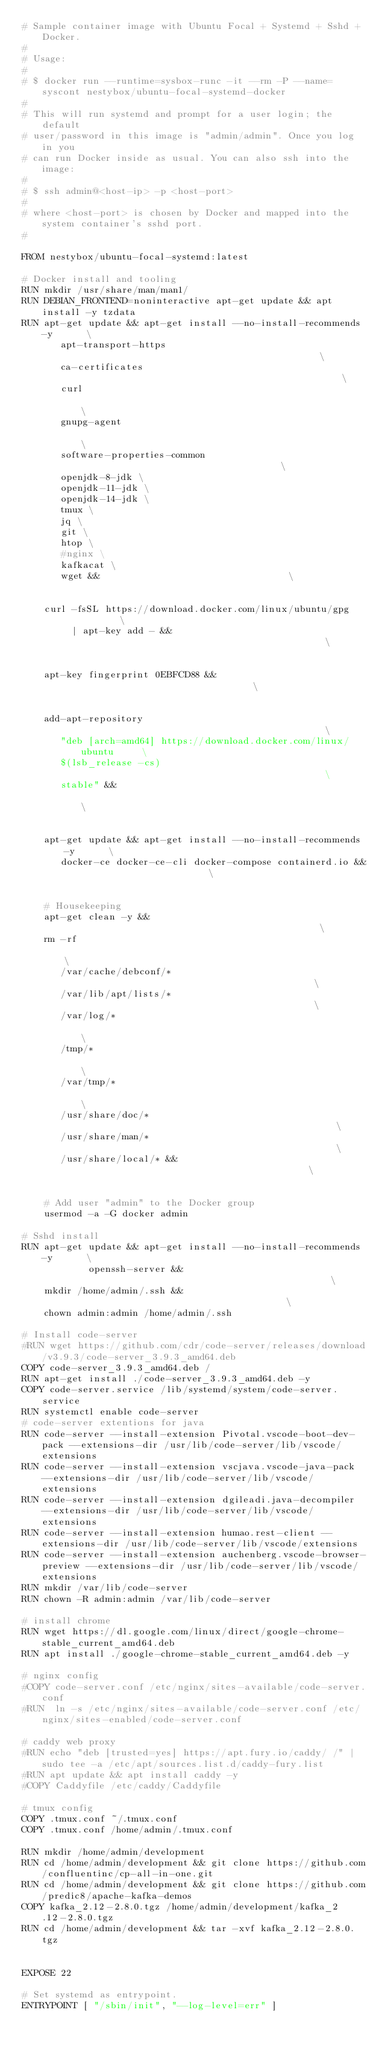Convert code to text. <code><loc_0><loc_0><loc_500><loc_500><_Dockerfile_># Sample container image with Ubuntu Focal + Systemd + Sshd + Docker.
#
# Usage:
#
# $ docker run --runtime=sysbox-runc -it --rm -P --name=syscont nestybox/ubuntu-focal-systemd-docker
#
# This will run systemd and prompt for a user login; the default
# user/password in this image is "admin/admin". Once you log in you
# can run Docker inside as usual. You can also ssh into the image:
#
# $ ssh admin@<host-ip> -p <host-port>
#
# where <host-port> is chosen by Docker and mapped into the system container's sshd port.
#

FROM nestybox/ubuntu-focal-systemd:latest

# Docker install and tooling
RUN mkdir /usr/share/man/man1/
RUN DEBIAN_FRONTEND=noninteractive apt-get update && apt install -y tzdata
RUN apt-get update && apt-get install --no-install-recommends -y      \
       apt-transport-https                                            \
       ca-certificates                                                \
       curl                                                           \
       gnupg-agent                                                    \
       software-properties-common                                     \
       openjdk-8-jdk \
       openjdk-11-jdk \
       openjdk-14-jdk \
       tmux \ 
       jq \ 
       git \
       htop \
       #nginx \
       kafkacat \
       wget &&                                  \
                                                                      \
    curl -fsSL https://download.docker.com/linux/ubuntu/gpg           \
         | apt-key add - &&                                           \
	                                                              \
    apt-key fingerprint 0EBFCD88 &&                                   \
                                                                      \
    add-apt-repository                                                \
       "deb [arch=amd64] https://download.docker.com/linux/ubuntu     \
       $(lsb_release -cs)                                             \
       stable" &&                                                     \
                                                                      \
    apt-get update && apt-get install --no-install-recommends -y      \
       docker-ce docker-ce-cli docker-compose containerd.io &&                       \
                                                                      \
    # Housekeeping
    apt-get clean -y &&                                               \
    rm -rf                                                            \
       /var/cache/debconf/*                                           \
       /var/lib/apt/lists/*                                           \
       /var/log/*                                                     \
       /tmp/*                                                         \
       /var/tmp/*                                                     \
       /usr/share/doc/*                                               \
       /usr/share/man/*                                               \
       /usr/share/local/* &&                                          \
                                                                      \
    # Add user "admin" to the Docker group
    usermod -a -G docker admin

# Sshd install
RUN apt-get update && apt-get install --no-install-recommends -y      \
            openssh-server &&                                         \
    mkdir /home/admin/.ssh &&                                         \
    chown admin:admin /home/admin/.ssh

# Install code-server
#RUN wget https://github.com/cdr/code-server/releases/download/v3.9.3/code-server_3.9.3_amd64.deb
COPY code-server_3.9.3_amd64.deb /
RUN apt-get install ./code-server_3.9.3_amd64.deb -y
COPY code-server.service /lib/systemd/system/code-server.service
RUN systemctl enable code-server
# code-server extentions for java
RUN code-server --install-extension Pivotal.vscode-boot-dev-pack --extensions-dir /usr/lib/code-server/lib/vscode/extensions
RUN code-server --install-extension vscjava.vscode-java-pack --extensions-dir /usr/lib/code-server/lib/vscode/extensions
RUN code-server --install-extension dgileadi.java-decompiler --extensions-dir /usr/lib/code-server/lib/vscode/extensions
RUN code-server --install-extension humao.rest-client --extensions-dir /usr/lib/code-server/lib/vscode/extensions
RUN code-server --install-extension auchenberg.vscode-browser-preview --extensions-dir /usr/lib/code-server/lib/vscode/extensions
RUN mkdir /var/lib/code-server
RUN chown -R admin:admin /var/lib/code-server

# install chrome
RUN wget https://dl.google.com/linux/direct/google-chrome-stable_current_amd64.deb
RUN apt install ./google-chrome-stable_current_amd64.deb -y

# nginx config
#COPY code-server.conf /etc/nginx/sites-available/code-server.conf
#RUN  ln -s /etc/nginx/sites-available/code-server.conf /etc/nginx/sites-enabled/code-server.conf

# caddy web proxy
#RUN echo "deb [trusted=yes] https://apt.fury.io/caddy/ /" | sudo tee -a /etc/apt/sources.list.d/caddy-fury.list
#RUN apt update && apt install caddy -y
#COPY Caddyfile /etc/caddy/Caddyfile

# tmux config
COPY .tmux.conf ~/.tmux.conf
COPY .tmux.conf /home/admin/.tmux.conf

RUN mkdir /home/admin/development
RUN cd /home/admin/development && git clone https://github.com/confluentinc/cp-all-in-one.git
RUN cd /home/admin/development && git clone https://github.com/predic8/apache-kafka-demos
COPY kafka_2.12-2.8.0.tgz /home/admin/development/kafka_2.12-2.8.0.tgz
RUN cd /home/admin/development && tar -xvf kafka_2.12-2.8.0.tgz


EXPOSE 22

# Set systemd as entrypoint.
ENTRYPOINT [ "/sbin/init", "--log-level=err" ]</code> 